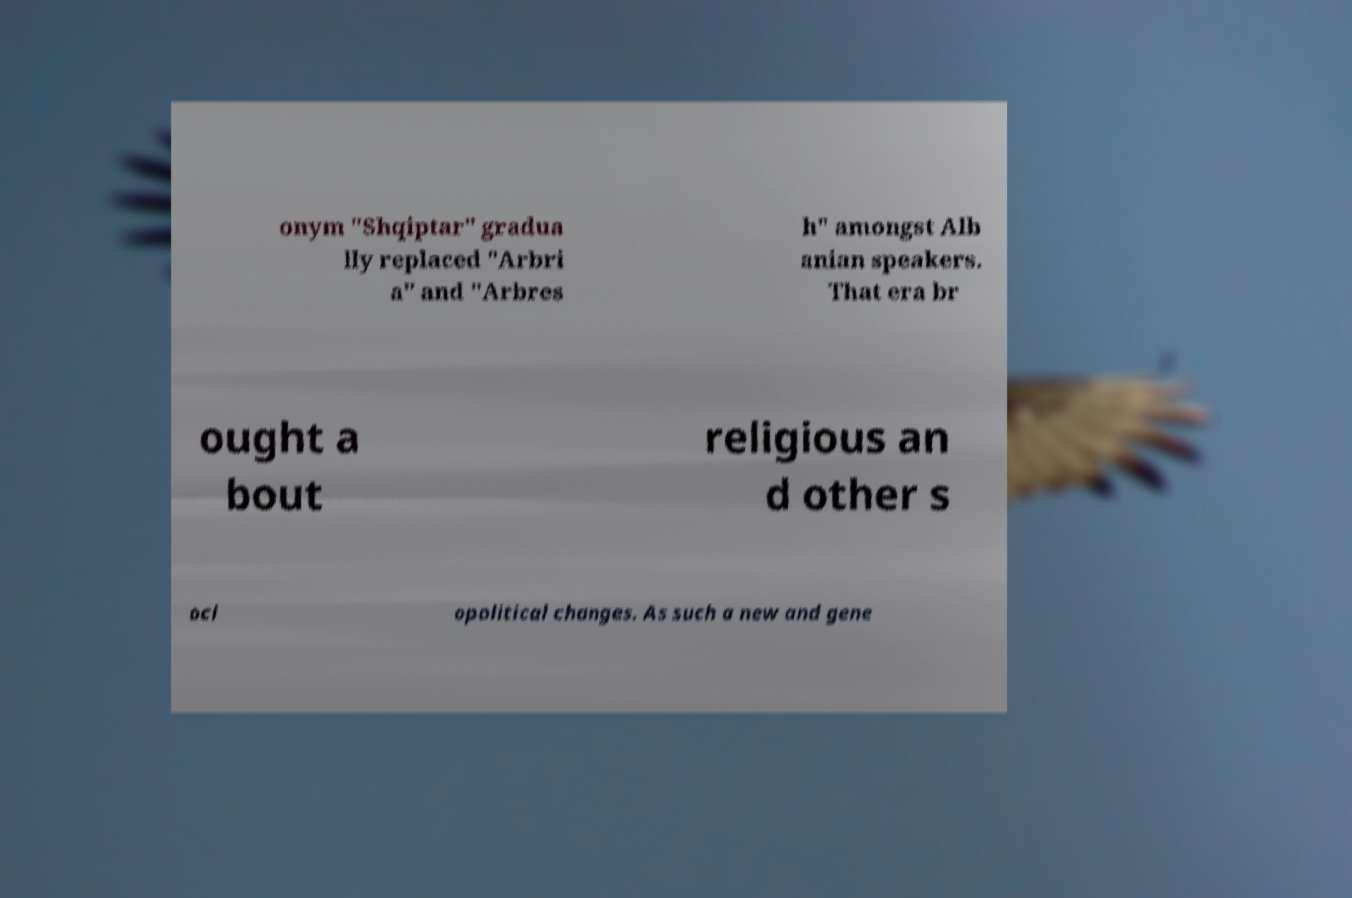I need the written content from this picture converted into text. Can you do that? onym "Shqiptar" gradua lly replaced "Arbri a" and "Arbres h" amongst Alb anian speakers. That era br ought a bout religious an d other s oci opolitical changes. As such a new and gene 